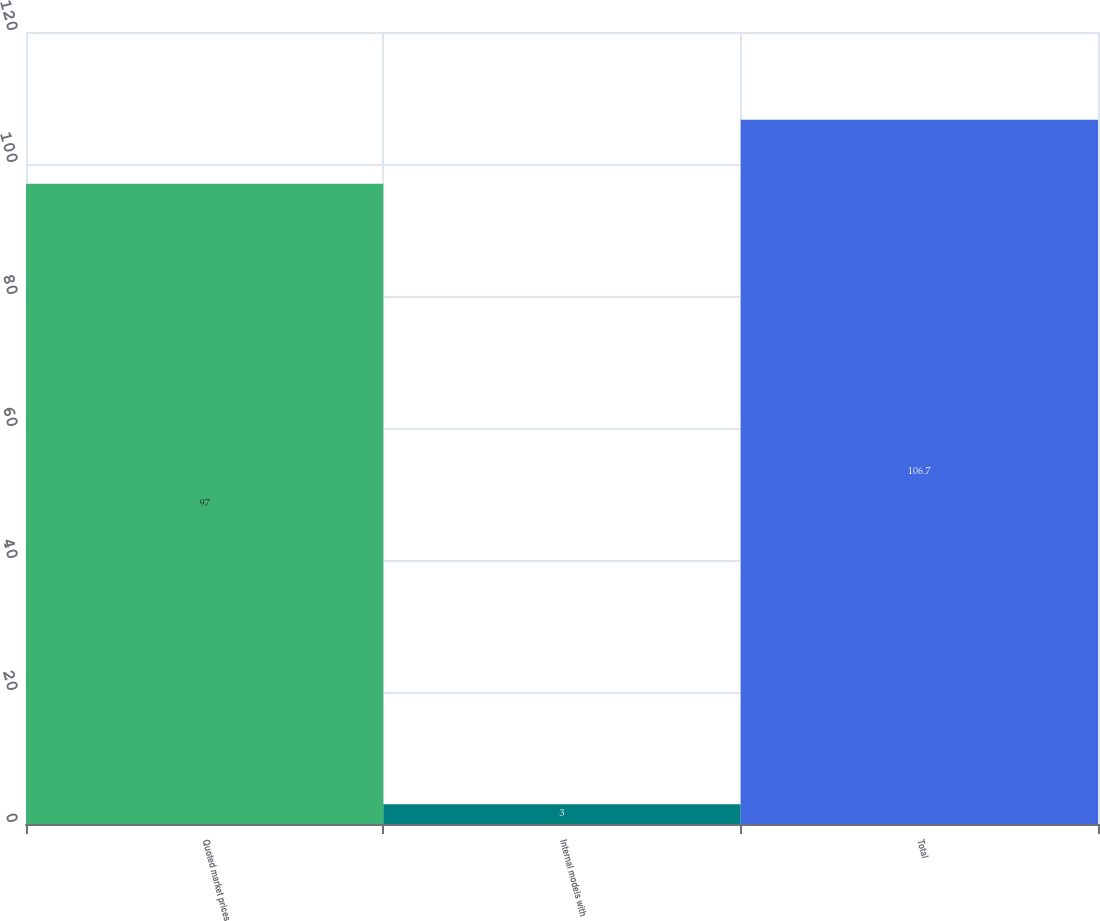Convert chart to OTSL. <chart><loc_0><loc_0><loc_500><loc_500><bar_chart><fcel>Quoted market prices<fcel>Internal models with<fcel>Total<nl><fcel>97<fcel>3<fcel>106.7<nl></chart> 